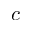Convert formula to latex. <formula><loc_0><loc_0><loc_500><loc_500>c</formula> 